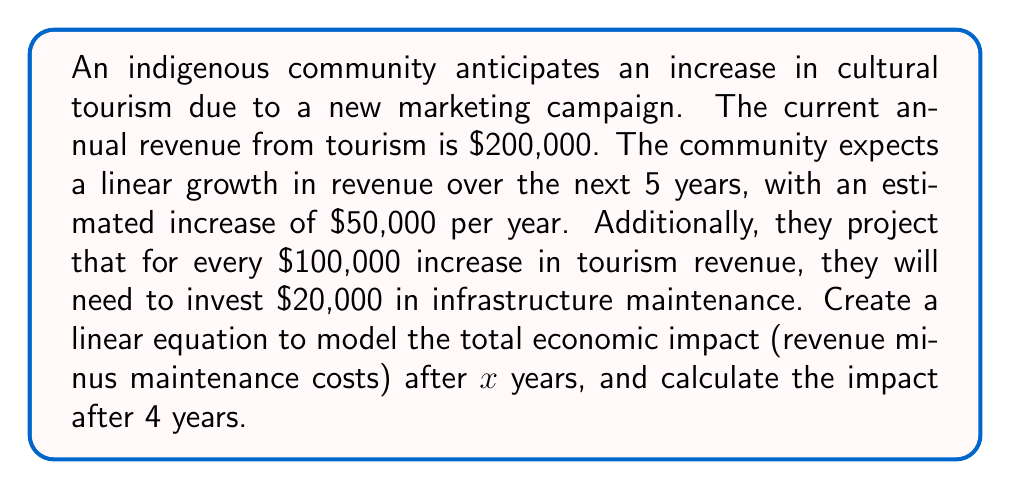What is the answer to this math problem? Let's approach this step-by-step:

1) First, let's model the revenue growth:
   - Initial revenue: $200,000
   - Annual increase: $50,000
   - After x years: $200,000 + $50,000x

2) Now, let's consider the maintenance costs:
   - For every $100,000 increase, $20,000 is spent on maintenance
   - This is equivalent to 20% of the revenue increase

3) The maintenance cost after x years can be modeled as:
   $0.2 * (50,000x) = 10,000x$

4) The total economic impact is revenue minus maintenance costs:
   $$(200,000 + 50,000x) - 10,000x$$

5) Simplifying this equation:
   $$200,000 + 40,000x$$

6) This is our linear equation for the economic impact after x years.

7) To find the impact after 4 years, we substitute x = 4:
   $$200,000 + 40,000(4) = 200,000 + 160,000 = 360,000$$

Therefore, the total economic impact after 4 years is $360,000.
Answer: $360,000 